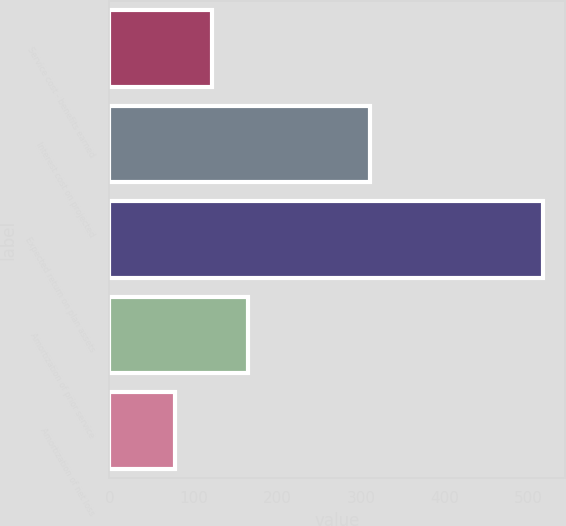Convert chart. <chart><loc_0><loc_0><loc_500><loc_500><bar_chart><fcel>Service cost - benefits earned<fcel>Interest cost on projected<fcel>Expected return on plan assets<fcel>Amortization of prior service<fcel>Amortization of net loss<nl><fcel>121.9<fcel>311<fcel>517<fcel>165.8<fcel>78<nl></chart> 